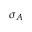<formula> <loc_0><loc_0><loc_500><loc_500>\sigma _ { A }</formula> 